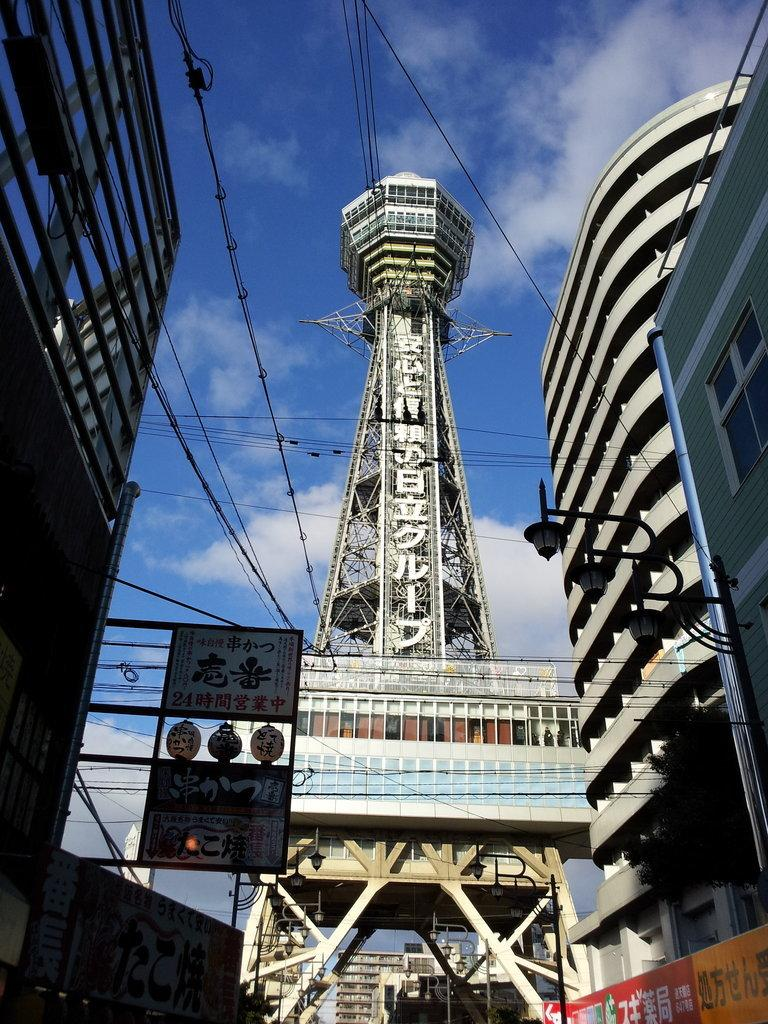What structures can be seen on both sides of the image? There are buildings on either side of the image. What is located in the middle of the image? There is a tower in the middle of the image. What can be seen hanging in the air in the image? There are wires hanging in the air. What is visible in the background of the image? The sky is visible in the image. What can be observed in the sky? Clouds are present in the sky. How many pizzas are being delivered to the buildings in the image? There is no indication of pizzas or deliveries in the image. 